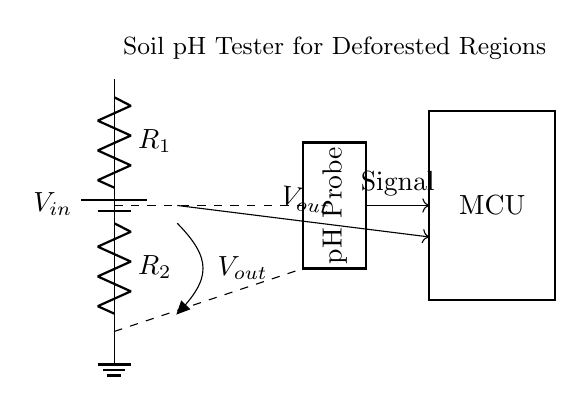What is the input voltage in the circuit? The input voltage, denoted as V_in, is the voltage supplied by the battery. This is indicated at the top of the circuit diagram, where the battery symbol is labeled with V_in.
Answer: V_in What are the two resistances used in the voltage divider? The two resistors, R_1 and R_2, are labeled in the circuit diagram. R_1 is positioned above R_2, as shown in the vertical arrangement of the resistors.
Answer: R_1 and R_2 What is the output voltage measured from this circuit? The output voltage, V_out, is taken from the junction between R_1 and R_2, as indicated by the label on the connection line. This is where the voltage divider function occurs in the circuit.
Answer: V_out How many components are in this voltage divider circuit? There are five main components visible: one battery, two resistors, one pH probe, and one microcontroller (MCU). Counting these components gives a total of five.
Answer: Five What type of circuit is this? This circuit is a voltage divider, which specifically is used to create a lower voltage output from a higher voltage input while using resistors in series. This functionality is particularly highlighted in the circuit's design.
Answer: Voltage Divider What role does the pH probe play in this circuit? The pH probe acts as a sensor that interacts with the soil sample, providing a signal related to the pH level, which is then measured by the output voltage in the voltage divider system.
Answer: Sensor What does the microcontroller (MCU) do in this setup? The microcontroller processes the voltage output (V_out) from the voltage divider and is responsible for interpreting the signal for further analysis or display related to the soil pH.
Answer: Processes signal 